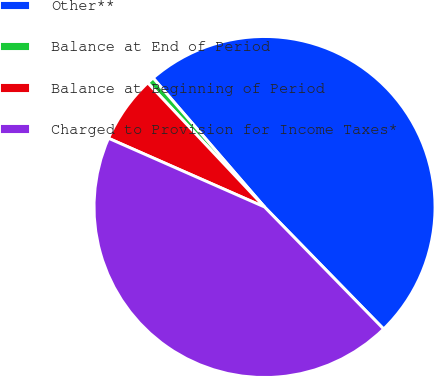Convert chart. <chart><loc_0><loc_0><loc_500><loc_500><pie_chart><fcel>Other**<fcel>Balance at End of Period<fcel>Balance at Beginning of Period<fcel>Charged to Provision for Income Taxes*<nl><fcel>49.03%<fcel>0.68%<fcel>6.38%<fcel>43.91%<nl></chart> 